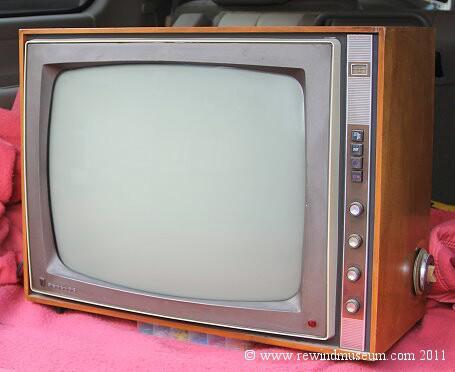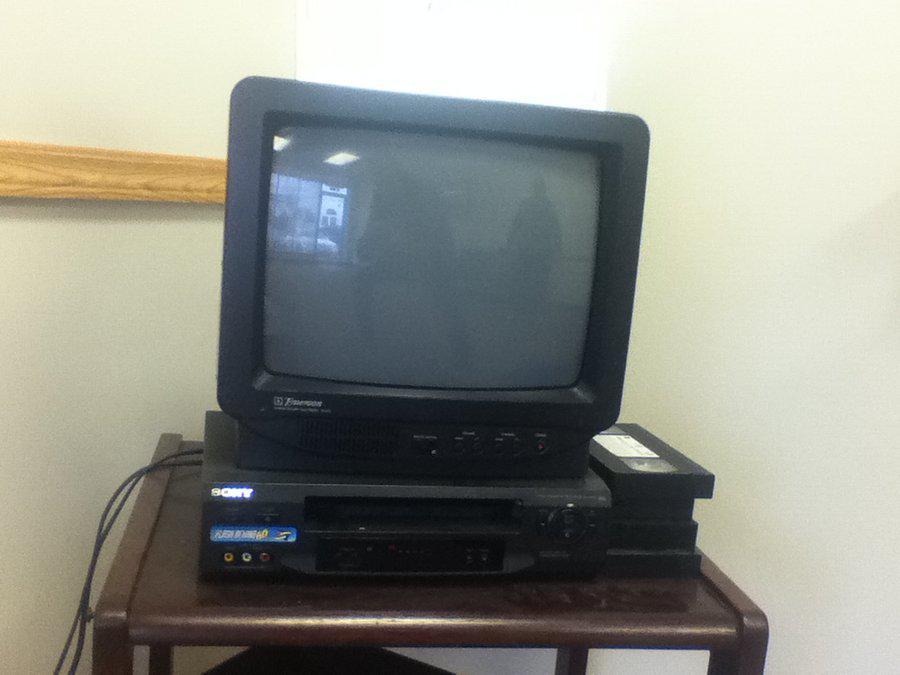The first image is the image on the left, the second image is the image on the right. Evaluate the accuracy of this statement regarding the images: "An image shows an old-fashioned wood-cased TV set elevated off the ground on some type of legs.". Is it true? Answer yes or no. No. The first image is the image on the left, the second image is the image on the right. Evaluate the accuracy of this statement regarding the images: "One of the televisions is not the console type.". Is it true? Answer yes or no. Yes. 